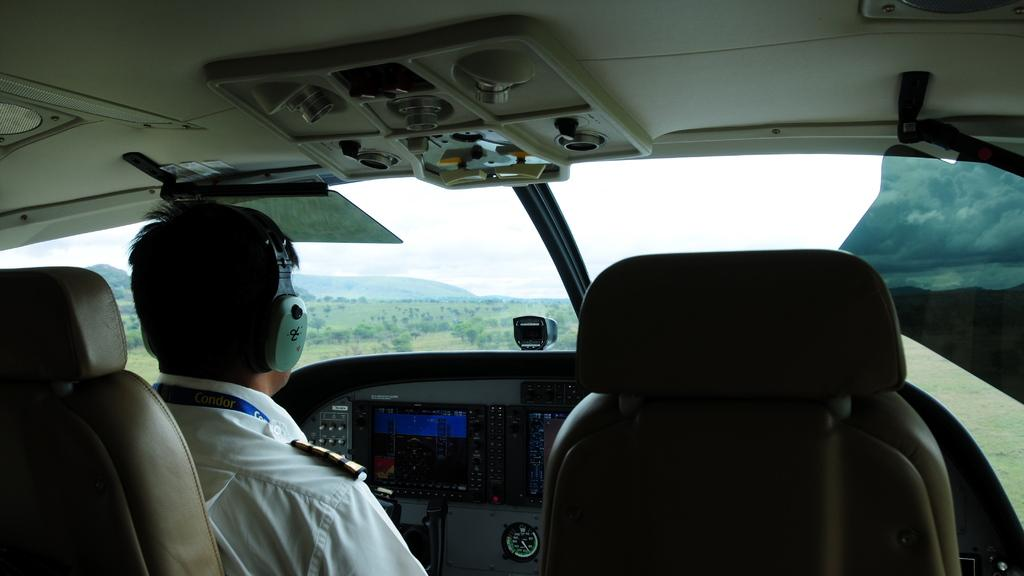What is the person in the image doing? There is a person sitting in the aircraft in the image. What can be seen in the background of the image? Trees and clouds are visible in the background of the image. What type of lunch is the person eating in the image? There is no indication in the image that the person is eating lunch, so it cannot be determined from the picture. 